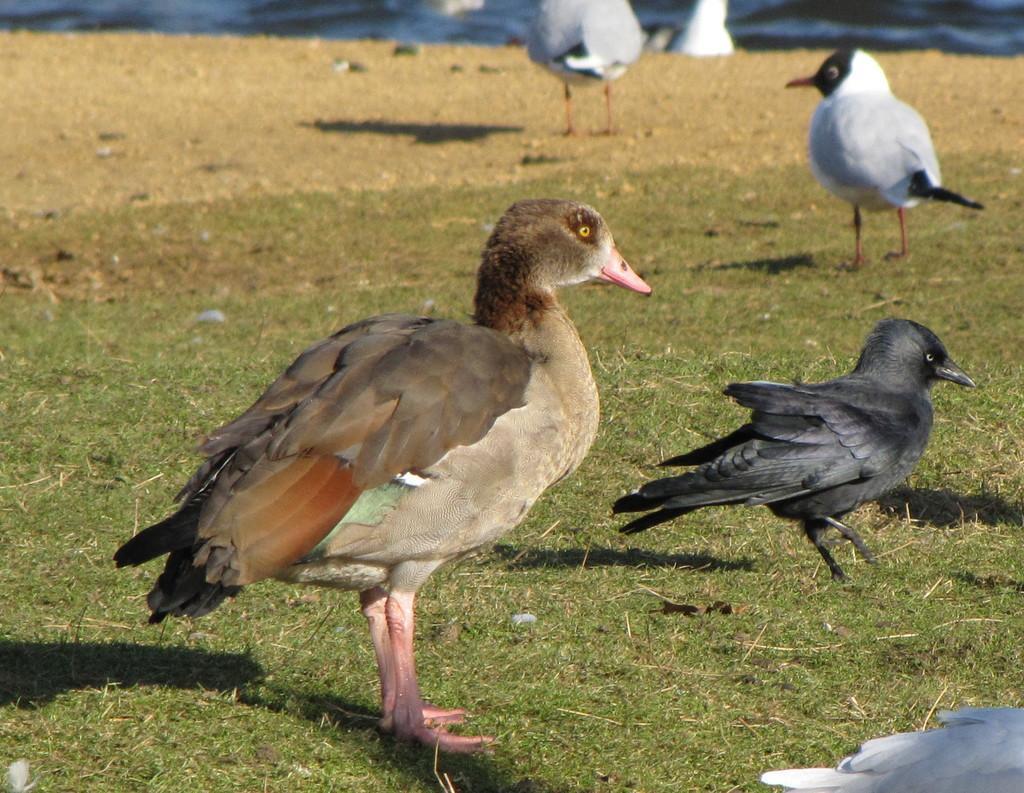Can you describe this image briefly? In this image I can see a bird which is grey, pink and brown in color is standing on the grass. I can see few other birds which are black, white and red in color on the ground in the background. 